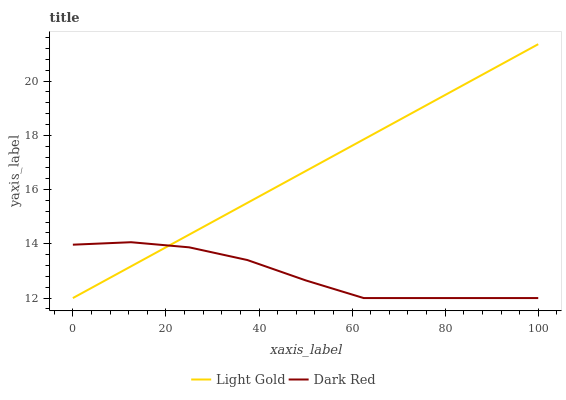Does Dark Red have the minimum area under the curve?
Answer yes or no. Yes. Does Light Gold have the maximum area under the curve?
Answer yes or no. Yes. Does Light Gold have the minimum area under the curve?
Answer yes or no. No. Is Light Gold the smoothest?
Answer yes or no. Yes. Is Dark Red the roughest?
Answer yes or no. Yes. Is Light Gold the roughest?
Answer yes or no. No. 